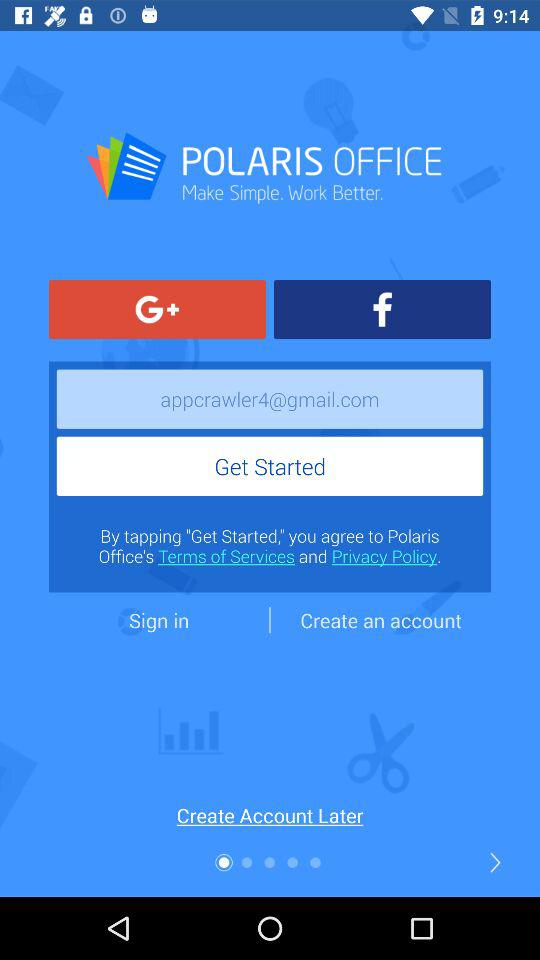What email address is used? The used email address is appcrawler4@gmail.com. 